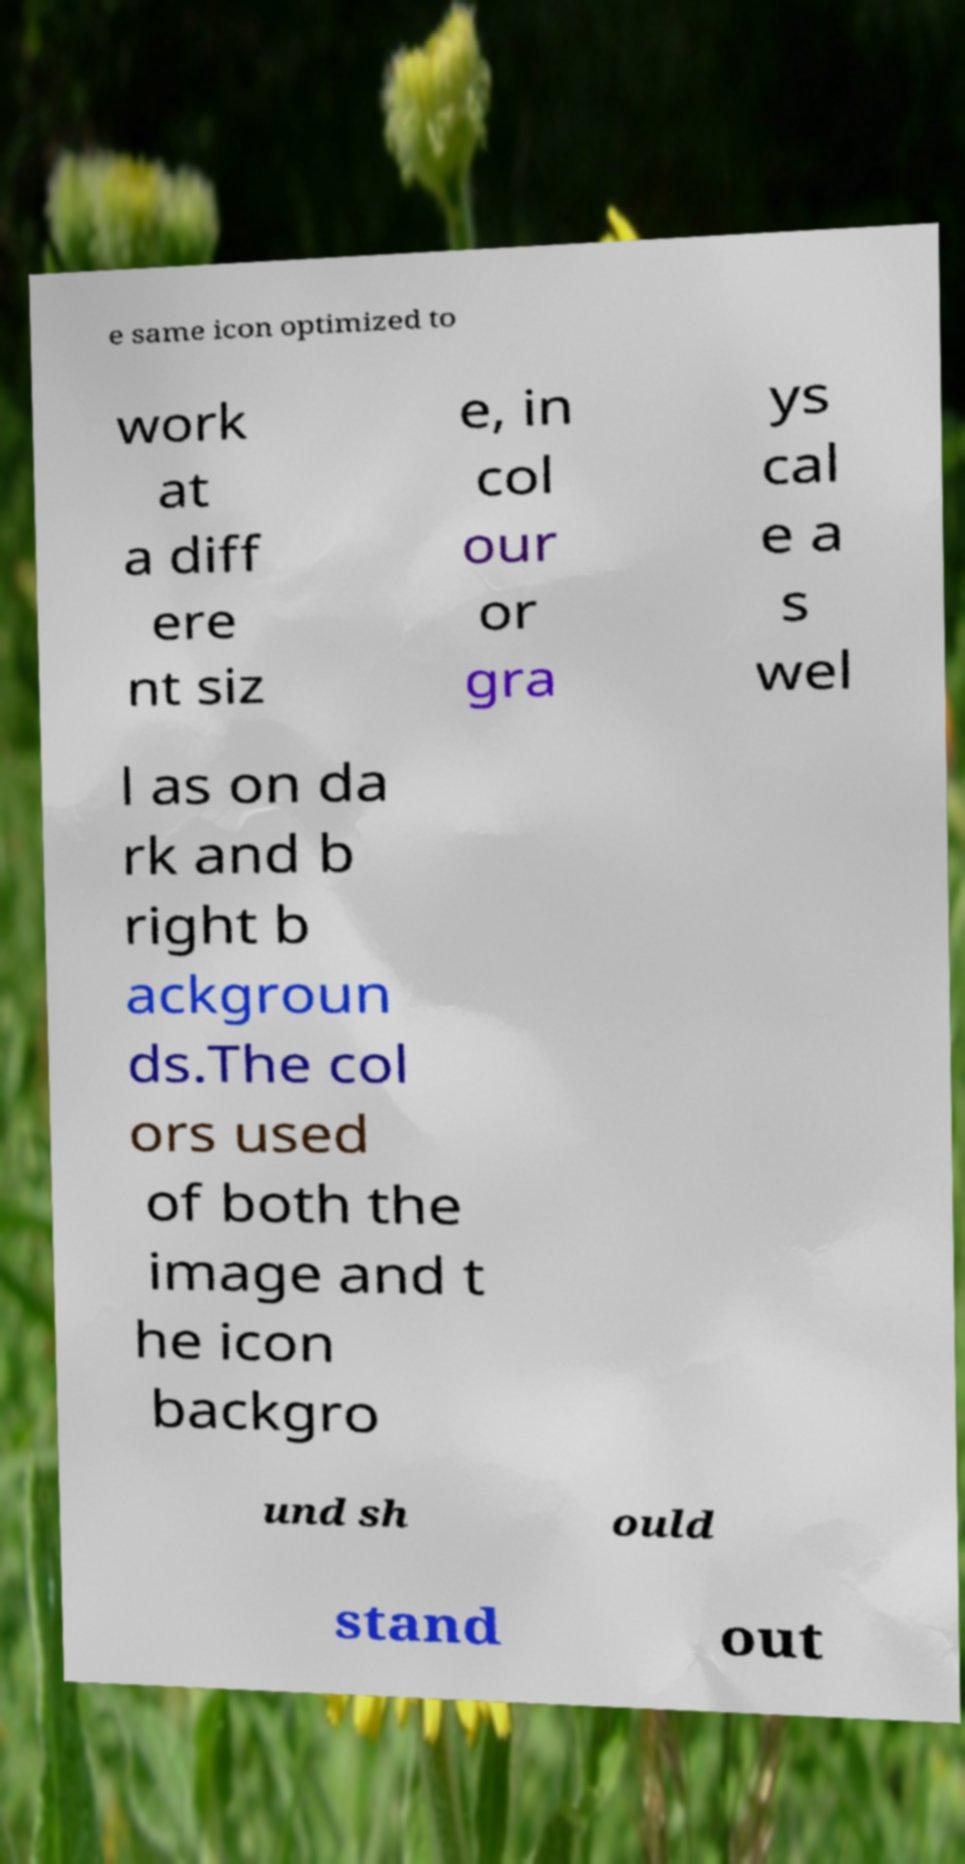Could you assist in decoding the text presented in this image and type it out clearly? e same icon optimized to work at a diff ere nt siz e, in col our or gra ys cal e a s wel l as on da rk and b right b ackgroun ds.The col ors used of both the image and t he icon backgro und sh ould stand out 